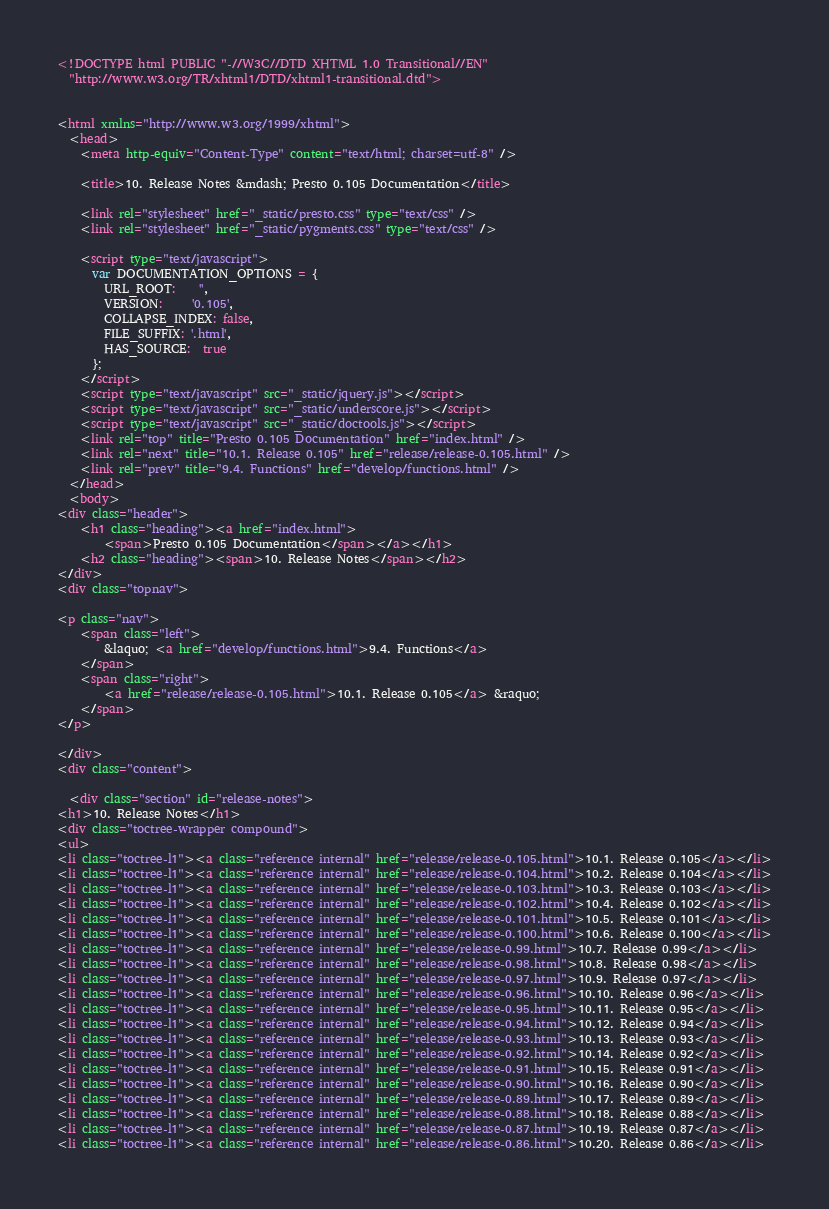<code> <loc_0><loc_0><loc_500><loc_500><_HTML_>
<!DOCTYPE html PUBLIC "-//W3C//DTD XHTML 1.0 Transitional//EN"
  "http://www.w3.org/TR/xhtml1/DTD/xhtml1-transitional.dtd">


<html xmlns="http://www.w3.org/1999/xhtml">
  <head>
    <meta http-equiv="Content-Type" content="text/html; charset=utf-8" />
    
    <title>10. Release Notes &mdash; Presto 0.105 Documentation</title>
    
    <link rel="stylesheet" href="_static/presto.css" type="text/css" />
    <link rel="stylesheet" href="_static/pygments.css" type="text/css" />
    
    <script type="text/javascript">
      var DOCUMENTATION_OPTIONS = {
        URL_ROOT:    '',
        VERSION:     '0.105',
        COLLAPSE_INDEX: false,
        FILE_SUFFIX: '.html',
        HAS_SOURCE:  true
      };
    </script>
    <script type="text/javascript" src="_static/jquery.js"></script>
    <script type="text/javascript" src="_static/underscore.js"></script>
    <script type="text/javascript" src="_static/doctools.js"></script>
    <link rel="top" title="Presto 0.105 Documentation" href="index.html" />
    <link rel="next" title="10.1. Release 0.105" href="release/release-0.105.html" />
    <link rel="prev" title="9.4. Functions" href="develop/functions.html" /> 
  </head>
  <body>
<div class="header">
    <h1 class="heading"><a href="index.html">
        <span>Presto 0.105 Documentation</span></a></h1>
    <h2 class="heading"><span>10. Release Notes</span></h2>
</div>
<div class="topnav">
    
<p class="nav">
    <span class="left">
        &laquo; <a href="develop/functions.html">9.4. Functions</a>
    </span>
    <span class="right">
        <a href="release/release-0.105.html">10.1. Release 0.105</a> &raquo;
    </span>
</p>

</div>
<div class="content">
    
  <div class="section" id="release-notes">
<h1>10. Release Notes</h1>
<div class="toctree-wrapper compound">
<ul>
<li class="toctree-l1"><a class="reference internal" href="release/release-0.105.html">10.1. Release 0.105</a></li>
<li class="toctree-l1"><a class="reference internal" href="release/release-0.104.html">10.2. Release 0.104</a></li>
<li class="toctree-l1"><a class="reference internal" href="release/release-0.103.html">10.3. Release 0.103</a></li>
<li class="toctree-l1"><a class="reference internal" href="release/release-0.102.html">10.4. Release 0.102</a></li>
<li class="toctree-l1"><a class="reference internal" href="release/release-0.101.html">10.5. Release 0.101</a></li>
<li class="toctree-l1"><a class="reference internal" href="release/release-0.100.html">10.6. Release 0.100</a></li>
<li class="toctree-l1"><a class="reference internal" href="release/release-0.99.html">10.7. Release 0.99</a></li>
<li class="toctree-l1"><a class="reference internal" href="release/release-0.98.html">10.8. Release 0.98</a></li>
<li class="toctree-l1"><a class="reference internal" href="release/release-0.97.html">10.9. Release 0.97</a></li>
<li class="toctree-l1"><a class="reference internal" href="release/release-0.96.html">10.10. Release 0.96</a></li>
<li class="toctree-l1"><a class="reference internal" href="release/release-0.95.html">10.11. Release 0.95</a></li>
<li class="toctree-l1"><a class="reference internal" href="release/release-0.94.html">10.12. Release 0.94</a></li>
<li class="toctree-l1"><a class="reference internal" href="release/release-0.93.html">10.13. Release 0.93</a></li>
<li class="toctree-l1"><a class="reference internal" href="release/release-0.92.html">10.14. Release 0.92</a></li>
<li class="toctree-l1"><a class="reference internal" href="release/release-0.91.html">10.15. Release 0.91</a></li>
<li class="toctree-l1"><a class="reference internal" href="release/release-0.90.html">10.16. Release 0.90</a></li>
<li class="toctree-l1"><a class="reference internal" href="release/release-0.89.html">10.17. Release 0.89</a></li>
<li class="toctree-l1"><a class="reference internal" href="release/release-0.88.html">10.18. Release 0.88</a></li>
<li class="toctree-l1"><a class="reference internal" href="release/release-0.87.html">10.19. Release 0.87</a></li>
<li class="toctree-l1"><a class="reference internal" href="release/release-0.86.html">10.20. Release 0.86</a></li></code> 